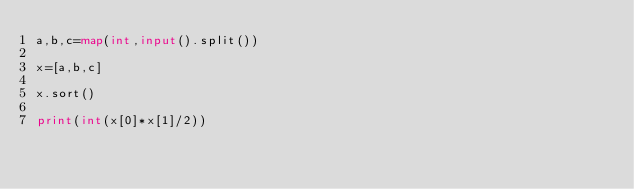<code> <loc_0><loc_0><loc_500><loc_500><_Python_>a,b,c=map(int,input().split())
 
x=[a,b,c]
 
x.sort()
 
print(int(x[0]*x[1]/2))</code> 